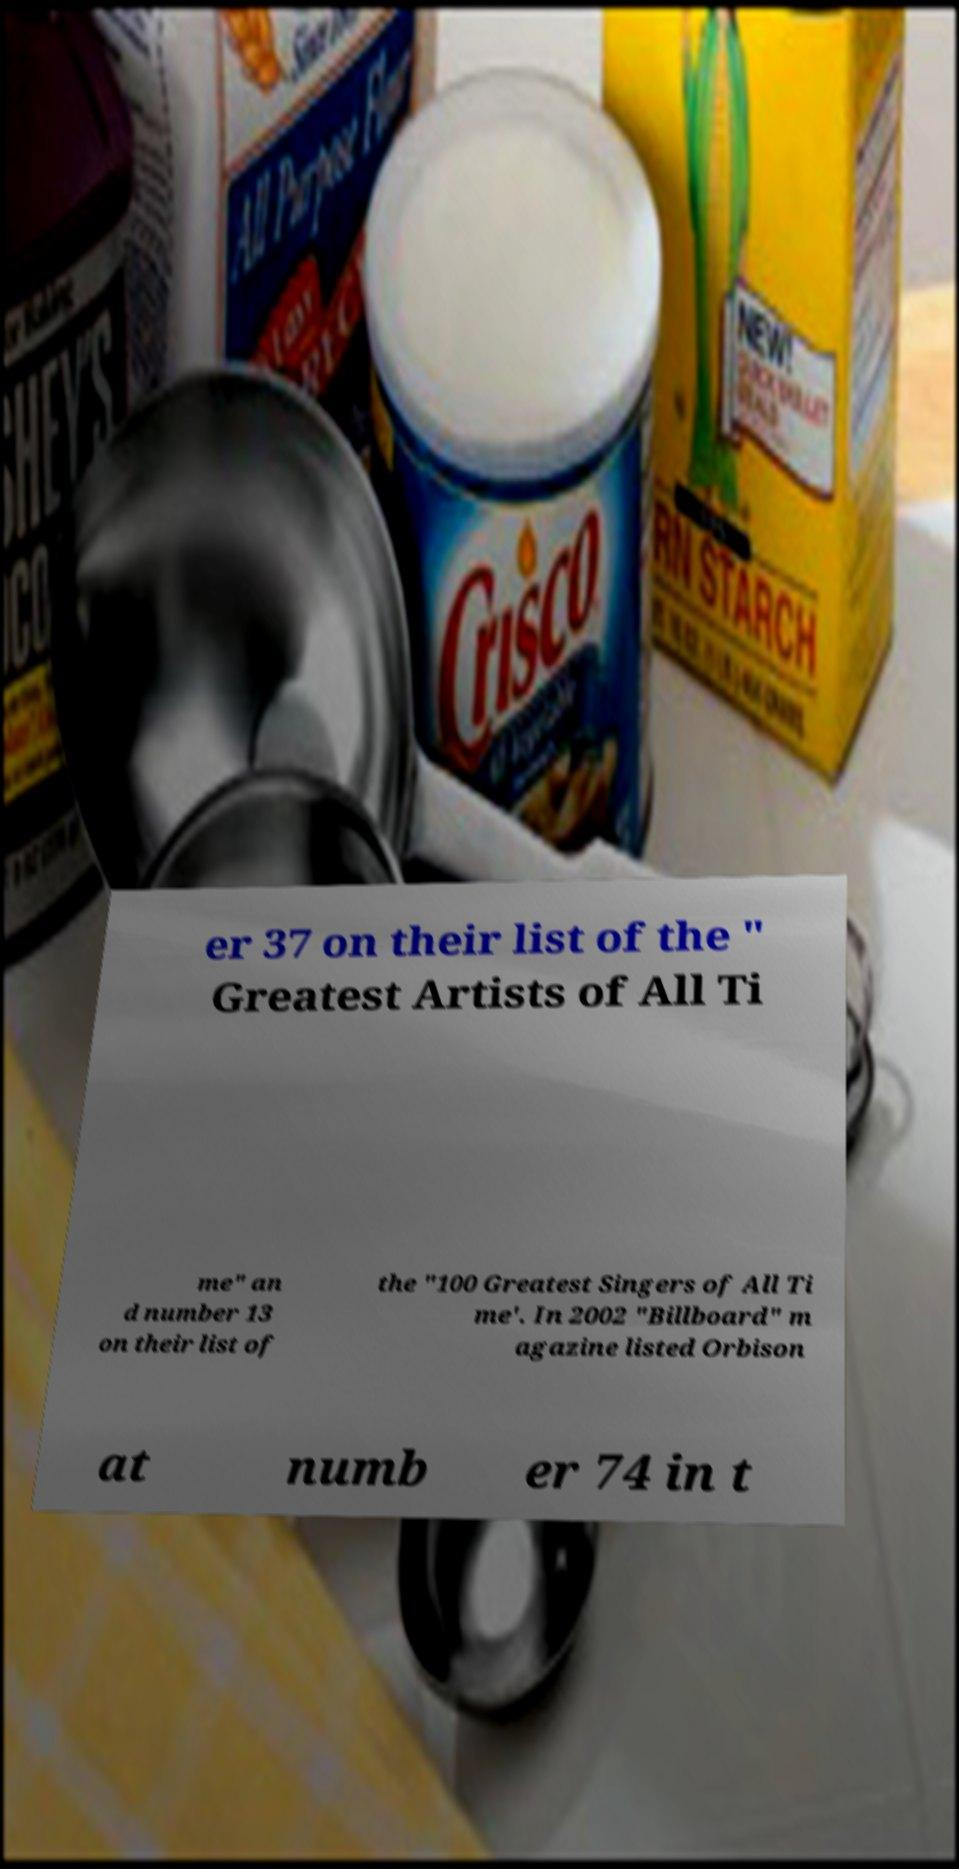Please read and relay the text visible in this image. What does it say? er 37 on their list of the " Greatest Artists of All Ti me" an d number 13 on their list of the "100 Greatest Singers of All Ti me'. In 2002 "Billboard" m agazine listed Orbison at numb er 74 in t 